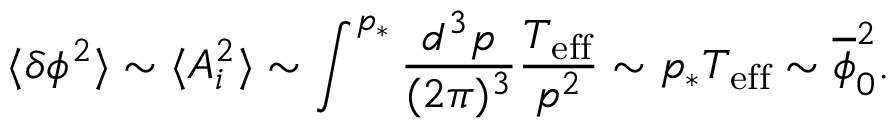<formula> <loc_0><loc_0><loc_500><loc_500>\langle \delta \phi ^ { 2 } \rangle \sim \langle A _ { i } ^ { 2 } \rangle \sim \int ^ { p _ { * } } \frac { d ^ { 3 } p } { ( 2 \pi ) ^ { 3 } } \frac { T _ { e f f } } { p ^ { 2 } } \sim p _ { * } T _ { e f f } \sim \overline { \phi } _ { 0 } ^ { 2 } .</formula> 